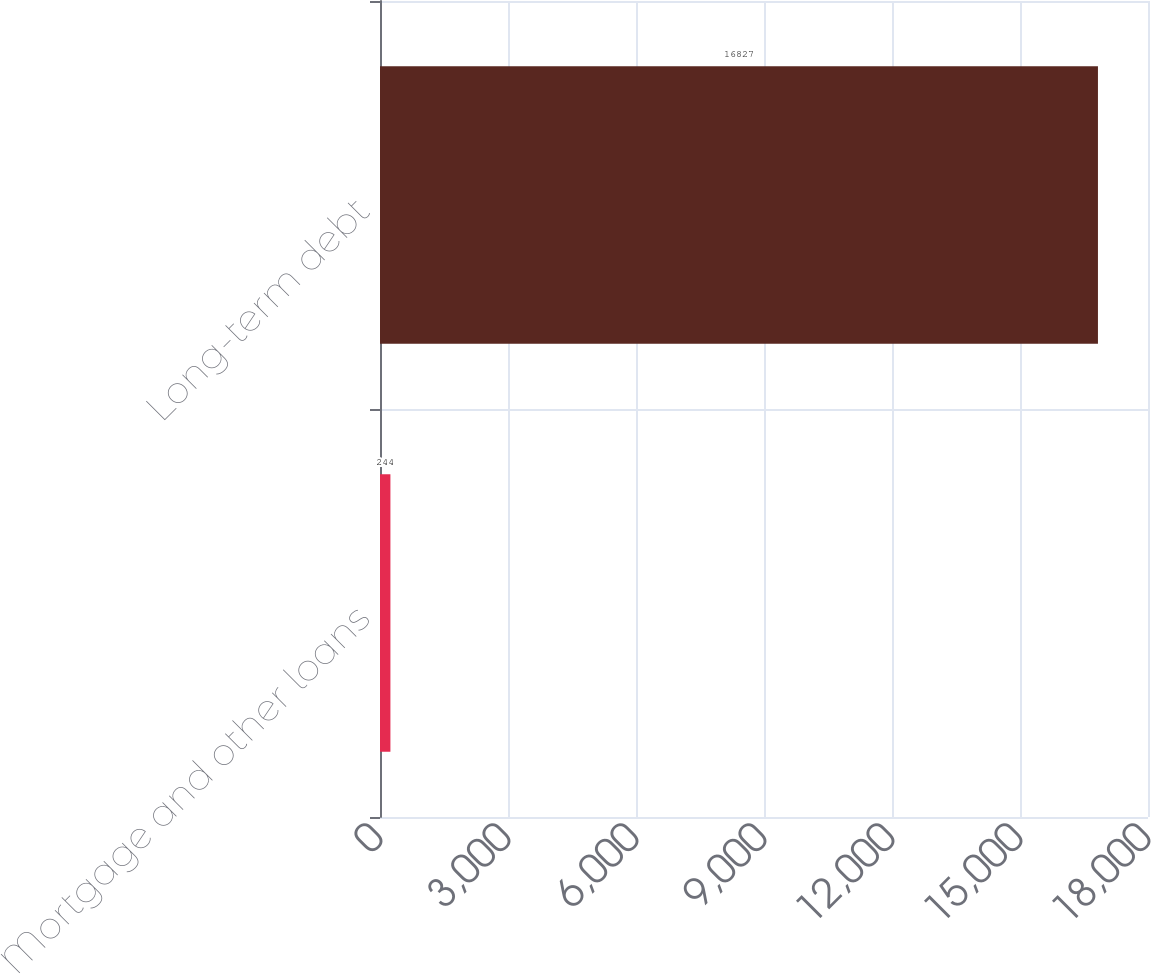Convert chart. <chart><loc_0><loc_0><loc_500><loc_500><bar_chart><fcel>Mortgage and other loans<fcel>Long-term debt<nl><fcel>244<fcel>16827<nl></chart> 